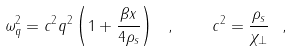<formula> <loc_0><loc_0><loc_500><loc_500>\omega _ { q } ^ { 2 } = c ^ { 2 } q ^ { 2 } \left ( 1 + \frac { \beta x } { 4 \rho _ { s } } \right ) \ , \quad c ^ { 2 } = \frac { \rho _ { s } } { \chi _ { \perp } } \ ,</formula> 